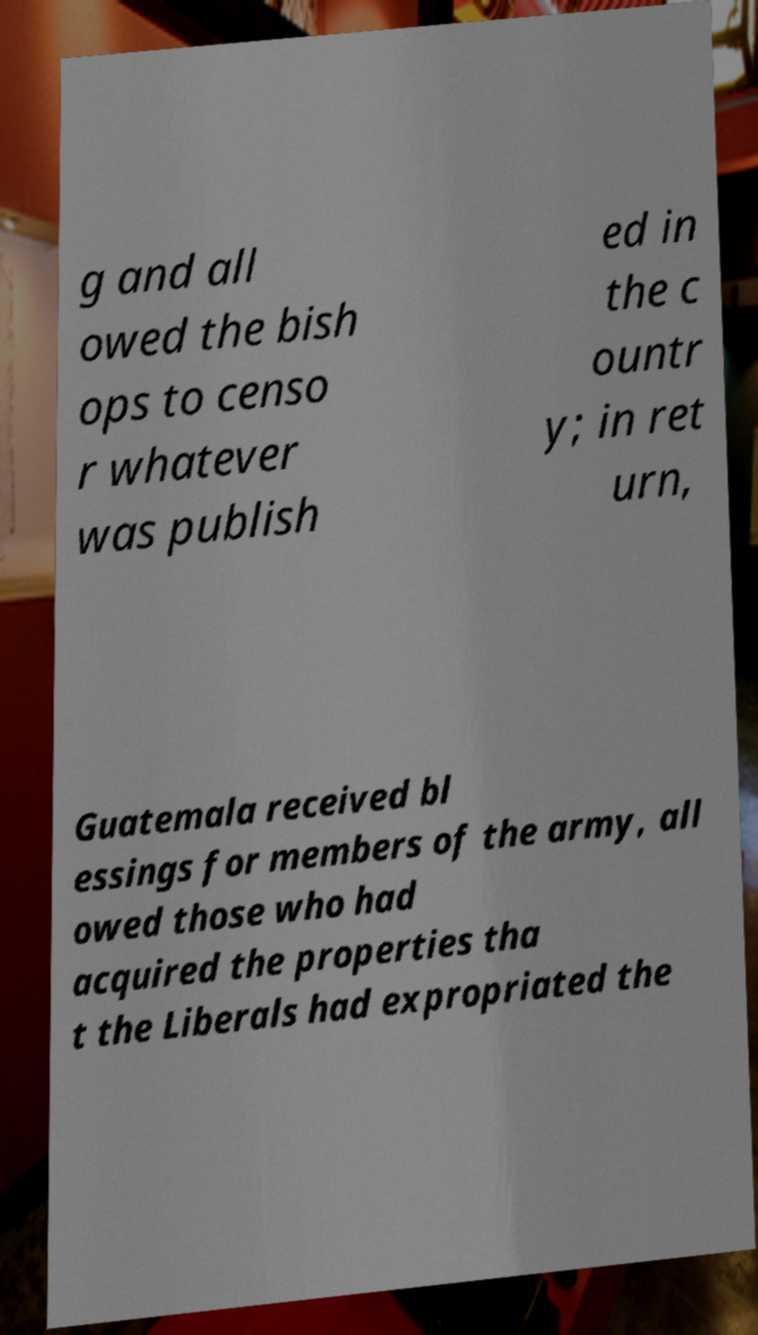Please read and relay the text visible in this image. What does it say? g and all owed the bish ops to censo r whatever was publish ed in the c ountr y; in ret urn, Guatemala received bl essings for members of the army, all owed those who had acquired the properties tha t the Liberals had expropriated the 